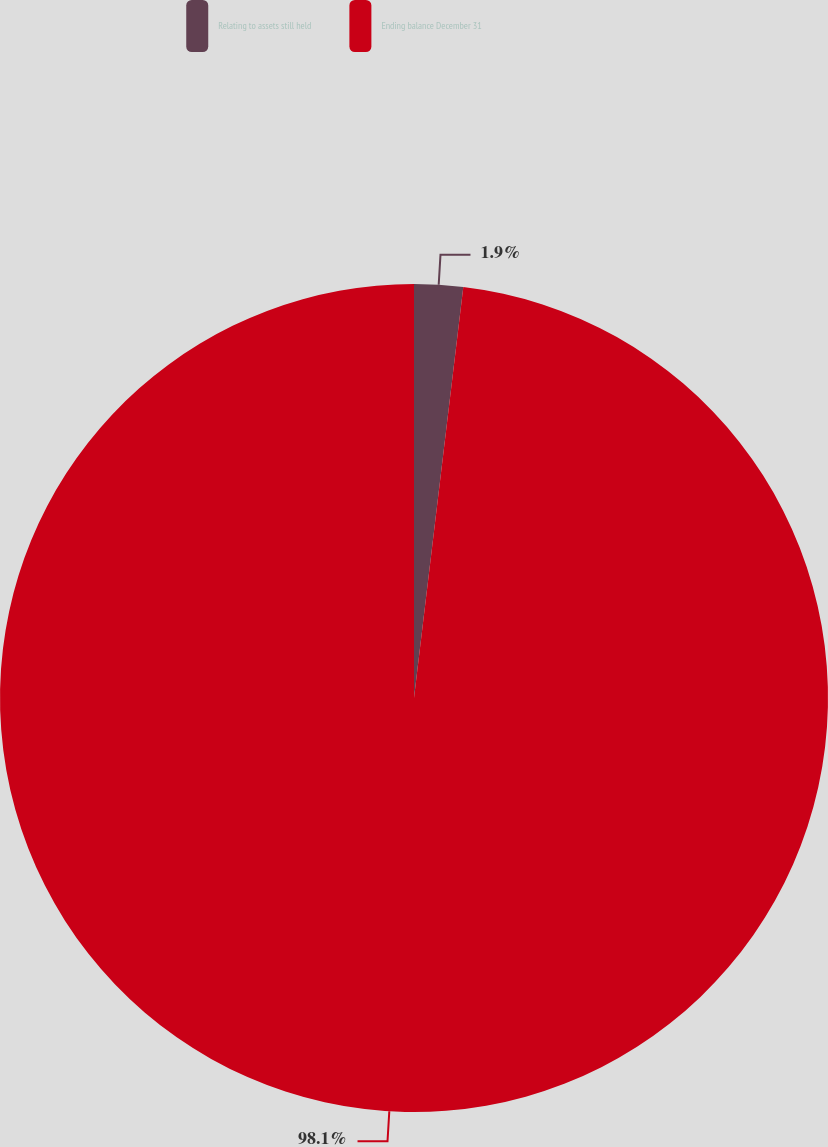Convert chart to OTSL. <chart><loc_0><loc_0><loc_500><loc_500><pie_chart><fcel>Relating to assets still held<fcel>Ending balance December 31<nl><fcel>1.9%<fcel>98.1%<nl></chart> 